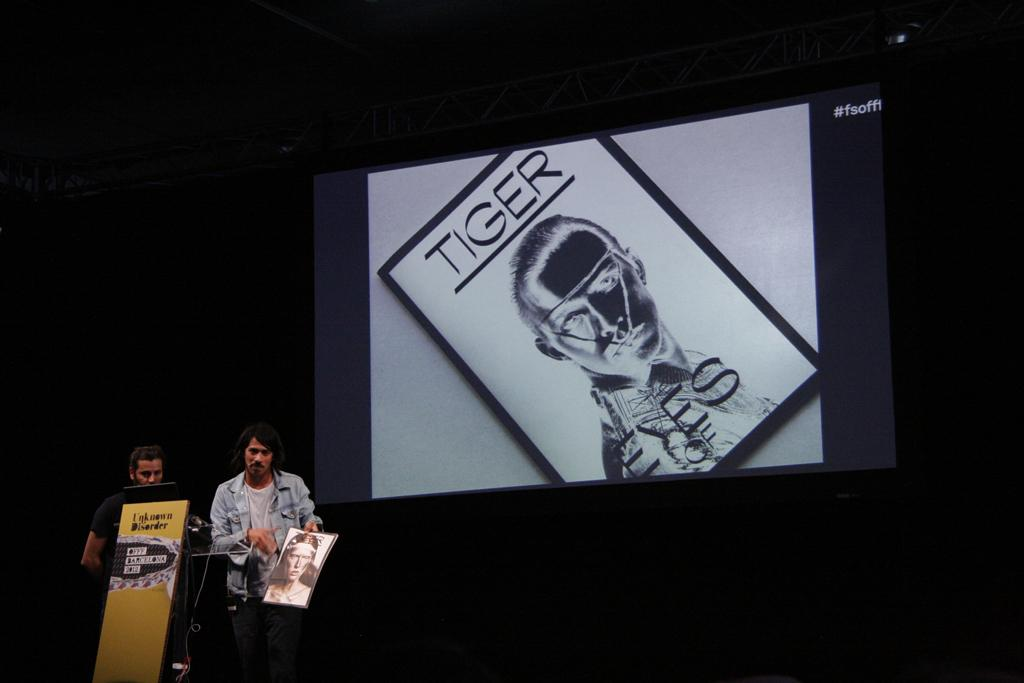How many people are standing near the podium in the image? There are two persons standing near the podium in the image. What is one of the persons holding? One of the persons is holding a paper. What can be seen in the background of the image? There is a screen and a lighting truss in the background. Can you tell me where the mom is sitting in the image? There is no mom present in the image. What type of mitten is the person wearing on the podium? There is no mitten visible in the image, as the person is not wearing any gloves or mittens. 